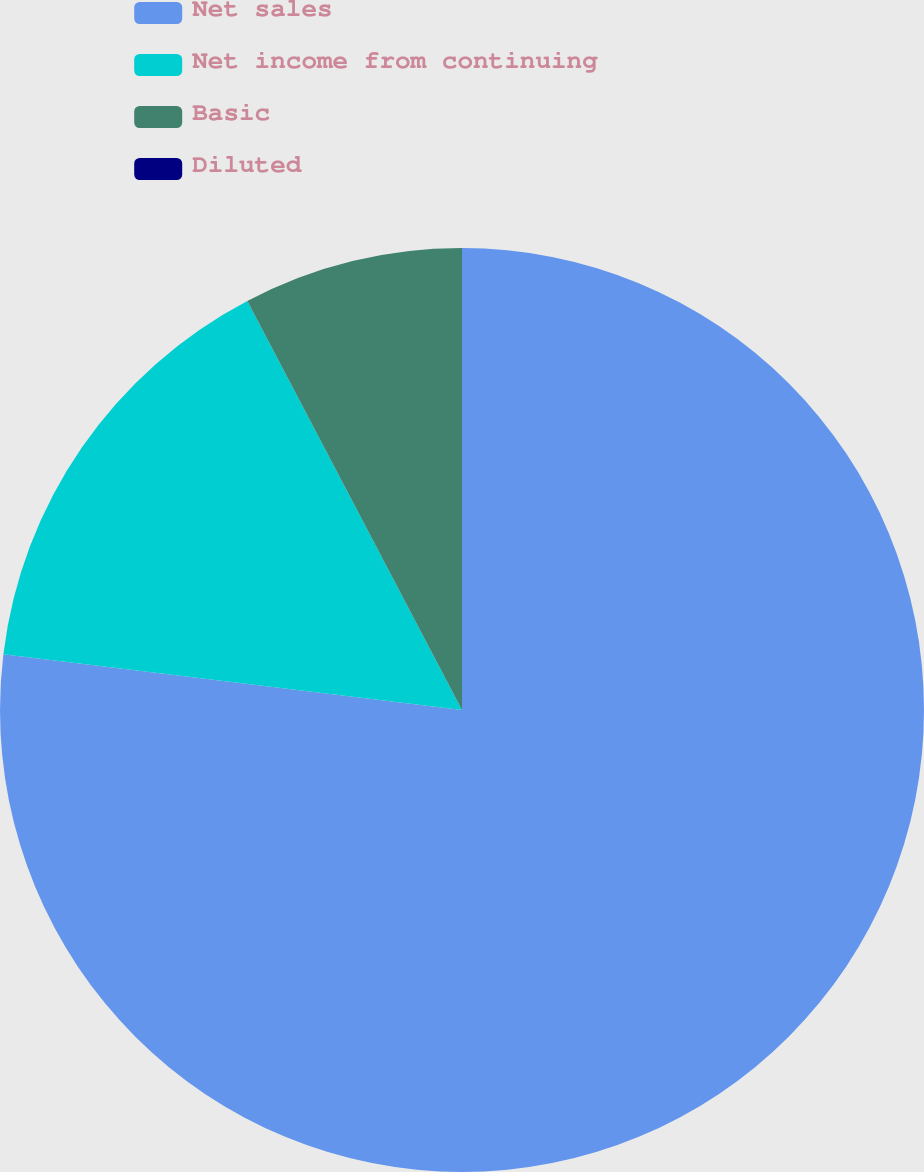Convert chart. <chart><loc_0><loc_0><loc_500><loc_500><pie_chart><fcel>Net sales<fcel>Net income from continuing<fcel>Basic<fcel>Diluted<nl><fcel>76.92%<fcel>15.38%<fcel>7.69%<fcel>0.0%<nl></chart> 